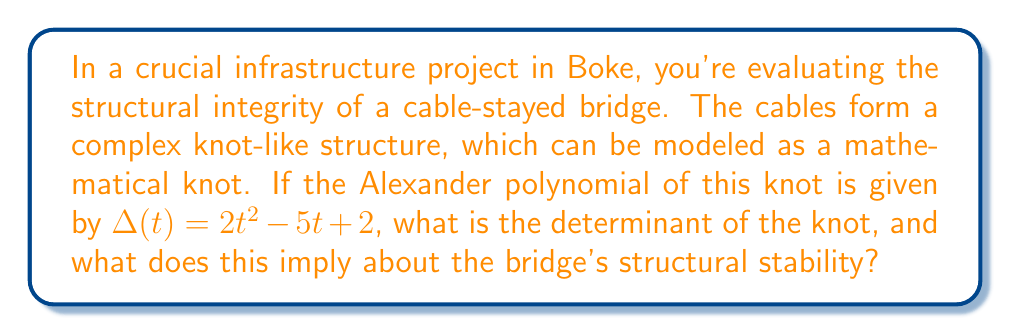Provide a solution to this math problem. To solve this problem, we'll follow these steps:

1) The determinant of a knot is defined as the absolute value of the Alexander polynomial evaluated at $t = -1$. 

2) Given Alexander polynomial: $\Delta(t) = 2t^2 - 5t + 2$

3) Evaluate $\Delta(-1)$:
   $$\Delta(-1) = 2(-1)^2 - 5(-1) + 2$$
   $$= 2(1) + 5 + 2$$
   $$= 9$$

4) The determinant is the absolute value of this result:
   $|\Delta(-1)| = |9| = 9$

5) Interpretation:
   - The determinant of a knot is always odd.
   - A higher determinant generally indicates a more complex knot structure.
   - In the context of the bridge, a determinant of 9 suggests a moderately complex cable configuration.
   - This complexity can contribute to the bridge's stability by distributing forces more evenly, but it also requires careful engineering to ensure all cables are properly tensioned.
   - The odd determinant confirms that the knot model is valid, supporting the reliability of this analysis for the bridge design.

6) For the governor overseeing the project, this result implies that the bridge design has a balanced level of complexity. It's not overly simple (which could be weak) nor excessively complex (which could be prone to construction errors). This suggests a good foundation for structural integrity, but careful implementation and regular maintenance will be crucial.
Answer: 9; moderately complex, potentially stable structure 